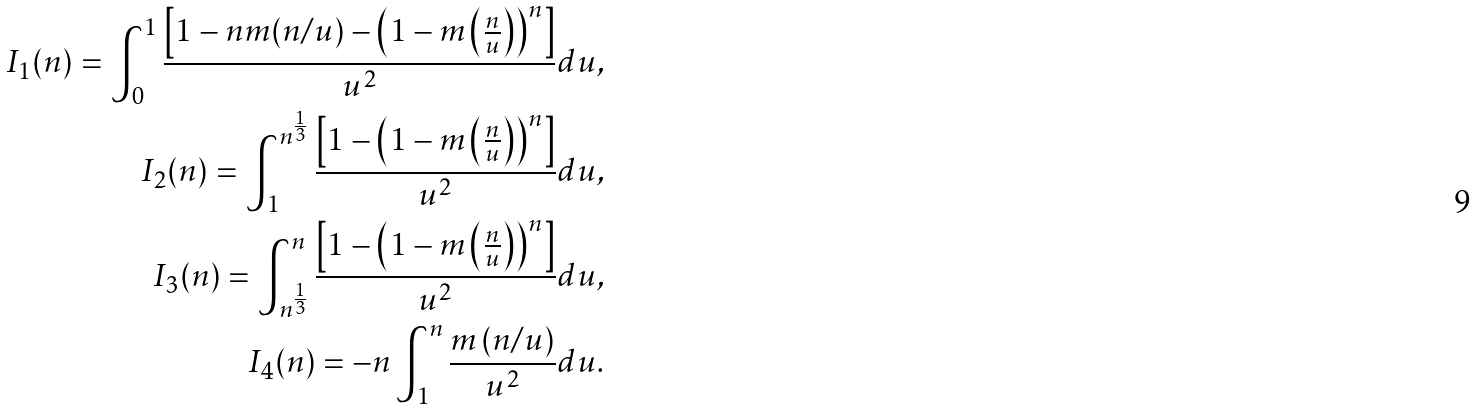Convert formula to latex. <formula><loc_0><loc_0><loc_500><loc_500>I _ { 1 } ( n ) = \int _ { 0 } ^ { 1 } \frac { \left [ 1 - n m ( n / u ) - \left ( 1 - m \left ( \frac { n } { u } \right ) \right ) ^ { n } \right ] } { u ^ { 2 } } d u , \\ I _ { 2 } ( n ) = \int _ { 1 } ^ { n ^ { \frac { 1 } { 3 } } } \frac { \left [ 1 - \left ( 1 - m \left ( \frac { n } { u } \right ) \right ) ^ { n } \right ] } { u ^ { 2 } } d u , \\ I _ { 3 } ( n ) = \int _ { n ^ { \frac { 1 } { 3 } } } ^ { n } \frac { \left [ 1 - \left ( 1 - m \left ( \frac { n } { u } \right ) \right ) ^ { n } \right ] } { u ^ { 2 } } d u , \\ I _ { 4 } ( n ) = - n \int _ { 1 } ^ { n } \frac { m \left ( n / u \right ) } { u ^ { 2 } } d u .</formula> 